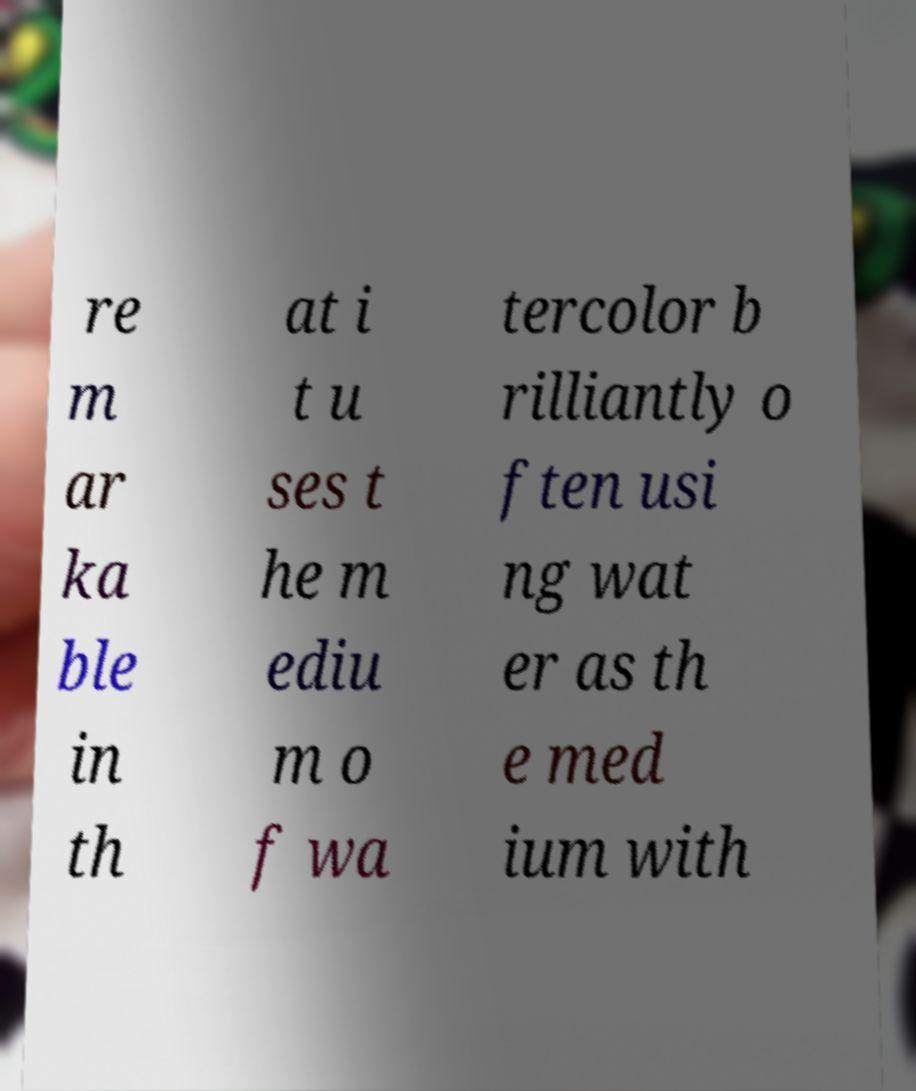Could you assist in decoding the text presented in this image and type it out clearly? re m ar ka ble in th at i t u ses t he m ediu m o f wa tercolor b rilliantly o ften usi ng wat er as th e med ium with 